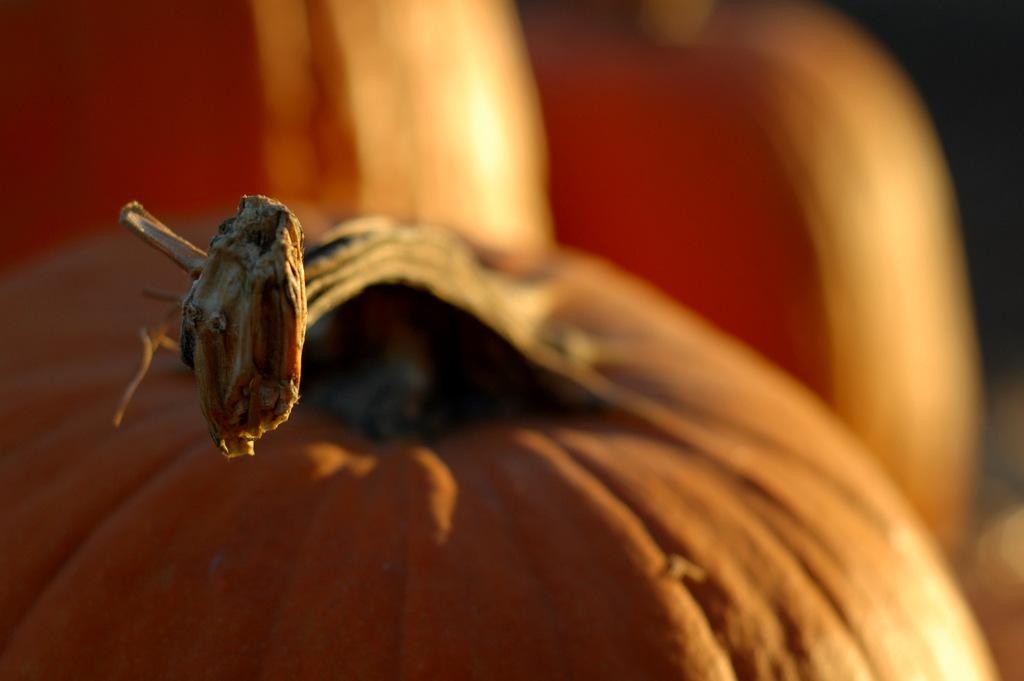What can be observed about the background of the image? The background portion of the picture is blurred. What objects are present in the image? There are pumpkins in the image. Can you see a flock of birds flying in the image? There is no mention of birds or a flock in the image; it only features pumpkins and a blurred background. 